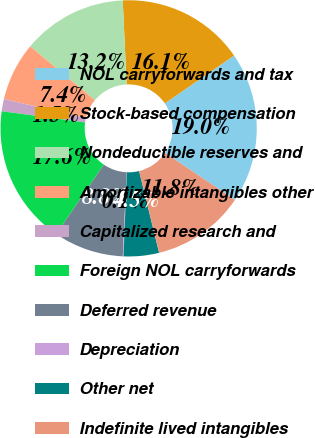Convert chart. <chart><loc_0><loc_0><loc_500><loc_500><pie_chart><fcel>NOL carryforwards and tax<fcel>Stock-based compensation<fcel>Nondeductible reserves and<fcel>Amortizable intangibles other<fcel>Capitalized research and<fcel>Foreign NOL carryforwards<fcel>Deferred revenue<fcel>Depreciation<fcel>Other net<fcel>Indefinite lived intangibles<nl><fcel>19.04%<fcel>16.12%<fcel>13.21%<fcel>7.38%<fcel>1.54%<fcel>17.58%<fcel>8.83%<fcel>0.09%<fcel>4.46%<fcel>11.75%<nl></chart> 